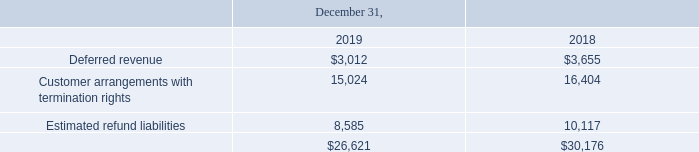Deferred Revenue and Customer Liabilities
Deferred revenue and customer liabilities consisted of the following (in thousands):
The Company expects to recognize the majority of its deferred revenue as of December 31, 2019 over the next 180 days. Revenues of $3.7 million were recognized during the year ended December 31, 2019 from amounts included in deferred revenue at December 31, 2018. Revenues of $4.4 million were recognized during the year ended December 31, 2018 from amounts included in deferred revenue at January 1, 2018.
The Company expects to recognize the majority of the customer arrangements with termination rights into revenue as the Company has not historically experienced a high rate of contract terminations.
Estimated refund liabilities are generally resolved in 180 days, once it is determined whether the requisite service levels and client requirements were achieved to settle the contingency.
Why does the Company expect to recognize the majority of the customer arrangements with termination rights into revenue? As the company has not historically experienced a high rate of contract terminations. How long do the estimated refund liabilities take to be generally resolved? 180 days, once it is determined whether the requisite service levels and client requirements were achieved to settle the contingency. What are the different types of components making up the deferred revenue and customer liabilities? Deferred revenue, customer arrangements with termination rights, estimated refund liabilities. In which year was deferred revenue larger? 3,655>3,012
Answer: 2018. What was the change in deferred revenue in 2019 from 2018?
Answer scale should be: thousand. 3,012-3,655
Answer: -643. What was the percentage change in deferred revenue in 2019 from 2018?
Answer scale should be: percent. (3,012-3,655)/3,655
Answer: -17.59. 